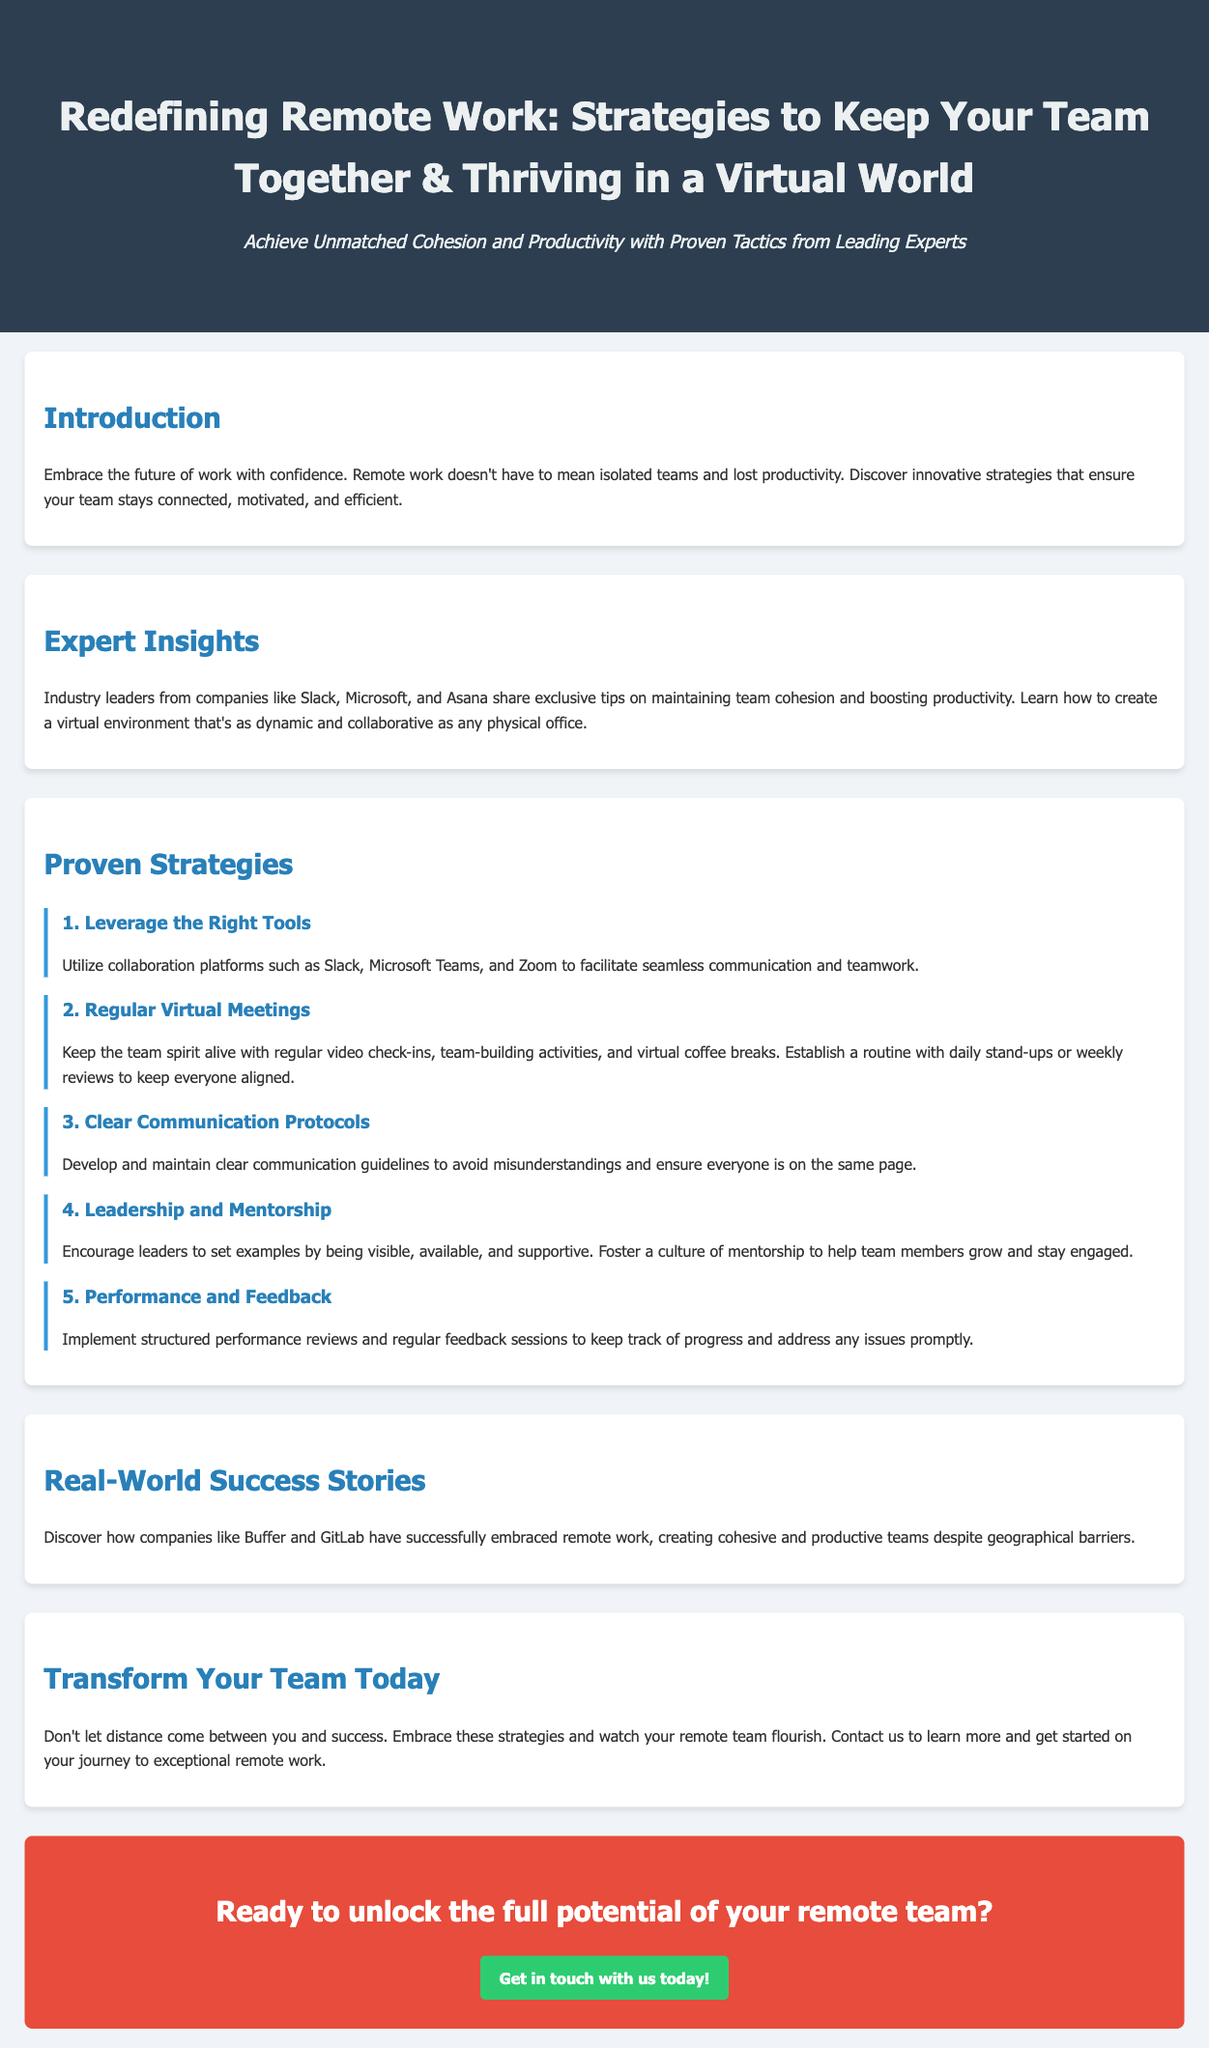What is the title of the advertisement? The title is the main heading that conveys the purpose of the advertisement.
Answer: Redefining Remote Work: Strategies to Keep Your Team Together & Thriving in a Virtual World Who shares exclusive tips for maintaining team cohesion? This refers to the industry leaders mentioned in the document.
Answer: Industry leaders from companies like Slack, Microsoft, and Asana What is one of the proven strategies listed? This is identified by one of the strategies provided in the document.
Answer: Leverage the Right Tools What type of meetings are suggested to keep the team spirit alive? This refers to the kinds of gatherings mentioned to enhance teamwork.
Answer: Regular Virtual Meetings Which companies are mentioned as real-world success stories? The document highlights companies that have successfully adopted remote work.
Answer: Buffer and GitLab What action does the advertisement suggest to transform your team? This question focuses on the call to action provided in the advertisement.
Answer: Embrace these strategies What color is used for the call-to-action button? This describes the design choice applied to the button in the advertisement.
Answer: Green 